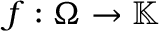Convert formula to latex. <formula><loc_0><loc_0><loc_500><loc_500>f \colon \Omega \rightarrow \mathbb { K }</formula> 